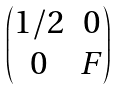<formula> <loc_0><loc_0><loc_500><loc_500>\begin{pmatrix} 1 / 2 & 0 \\ 0 & F \end{pmatrix}</formula> 